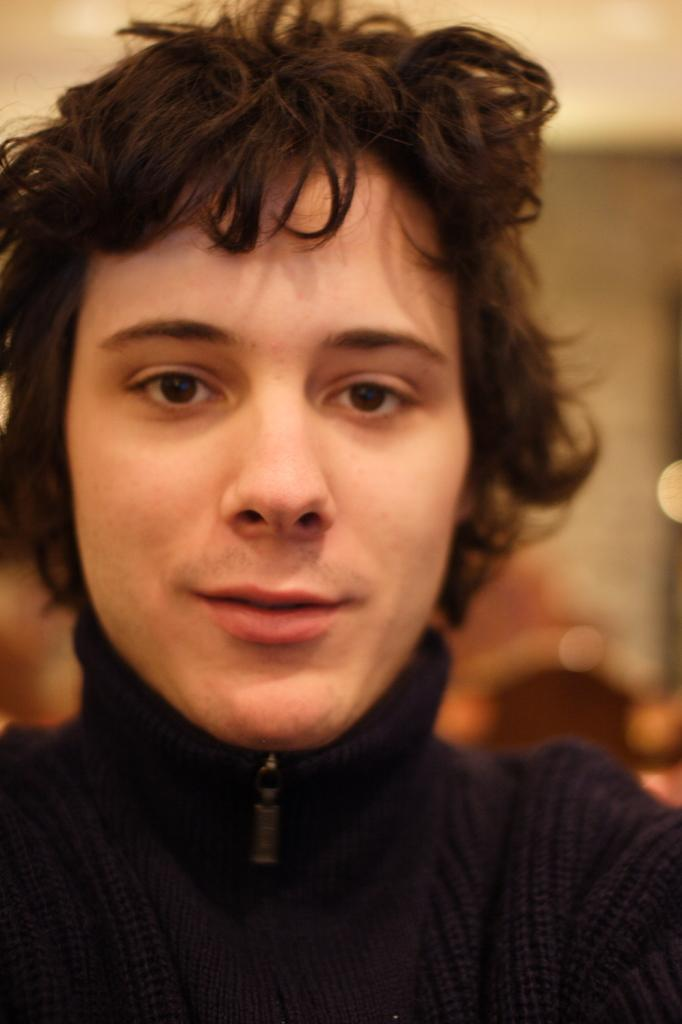What is the main subject of the image? There is a person in the image. Can you describe the background of the image? The background of the image is blurred. How many rabbits are visible in the image? There are no rabbits present in the image. What type of ring is the person wearing in the image? There is no ring visible on the person in the image. 